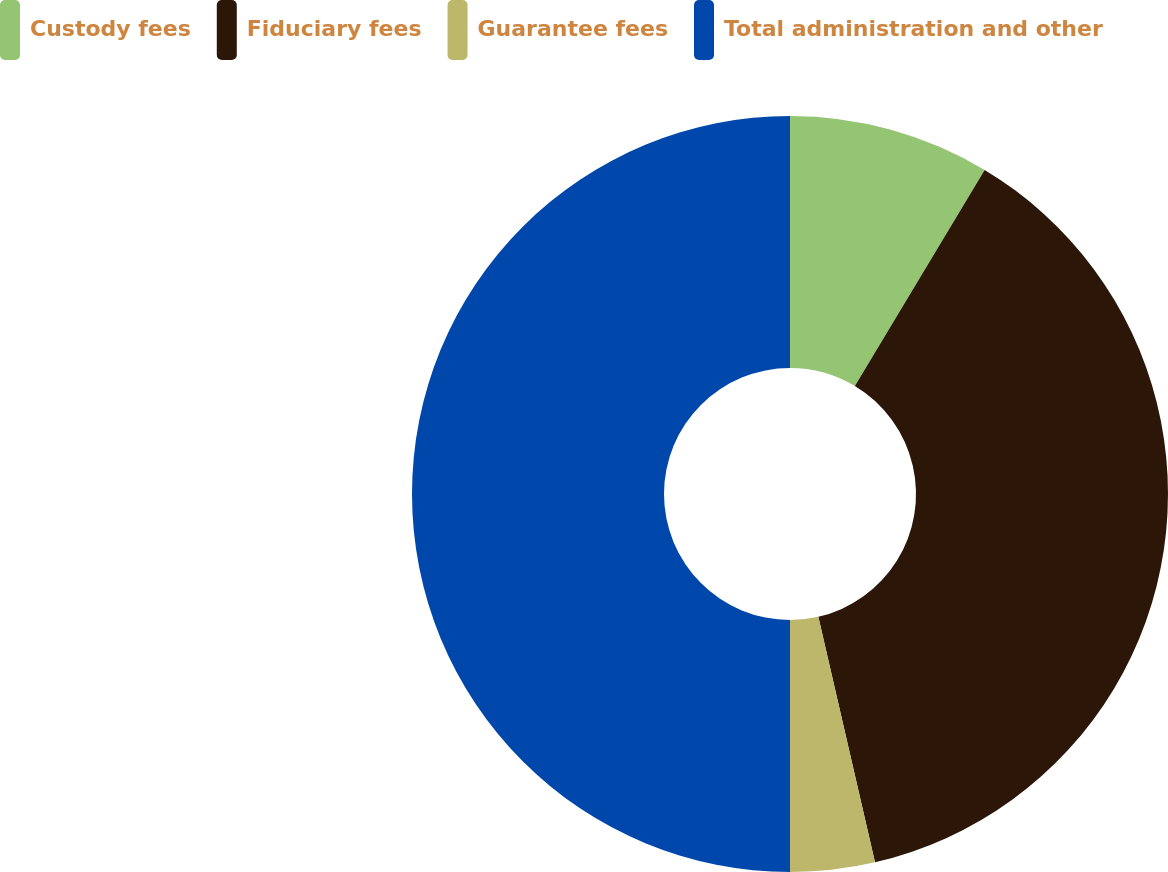Convert chart. <chart><loc_0><loc_0><loc_500><loc_500><pie_chart><fcel>Custody fees<fcel>Fiduciary fees<fcel>Guarantee fees<fcel>Total administration and other<nl><fcel>8.61%<fcel>37.78%<fcel>3.61%<fcel>50.0%<nl></chart> 